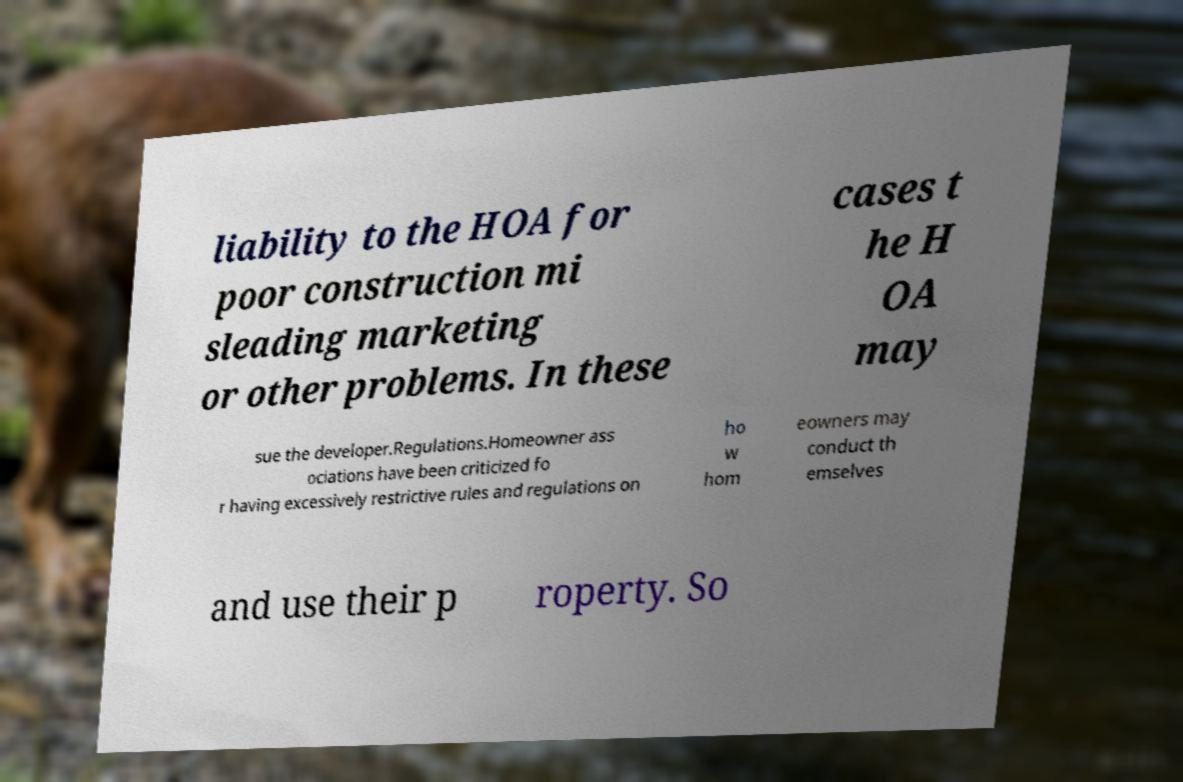Can you accurately transcribe the text from the provided image for me? liability to the HOA for poor construction mi sleading marketing or other problems. In these cases t he H OA may sue the developer.Regulations.Homeowner ass ociations have been criticized fo r having excessively restrictive rules and regulations on ho w hom eowners may conduct th emselves and use their p roperty. So 